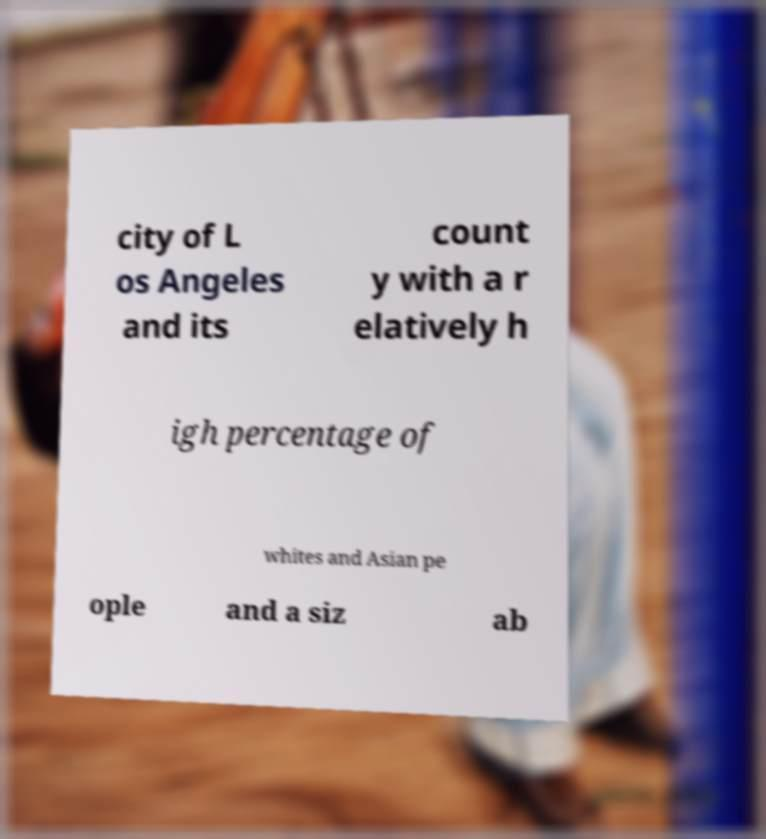What messages or text are displayed in this image? I need them in a readable, typed format. city of L os Angeles and its count y with a r elatively h igh percentage of whites and Asian pe ople and a siz ab 